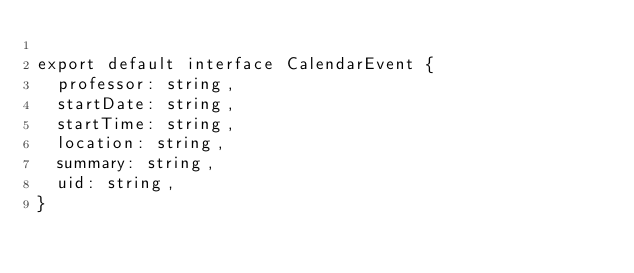Convert code to text. <code><loc_0><loc_0><loc_500><loc_500><_TypeScript_>
export default interface CalendarEvent {
  professor: string,
  startDate: string,
  startTime: string,
  location: string,
  summary: string,
  uid: string,
}
</code> 